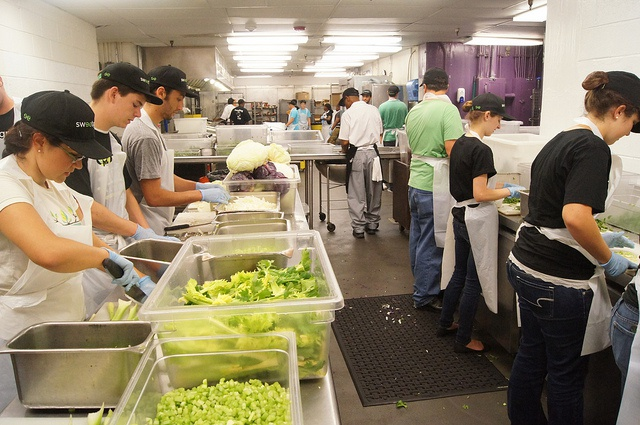Describe the objects in this image and their specific colors. I can see people in lightgray, black, tan, maroon, and gray tones, people in lightgray, tan, darkgray, black, and beige tones, people in lightgray, black, darkgray, tan, and gray tones, people in lightgray, black, gray, and lightgreen tones, and people in lightgray, brown, black, darkgray, and tan tones in this image. 